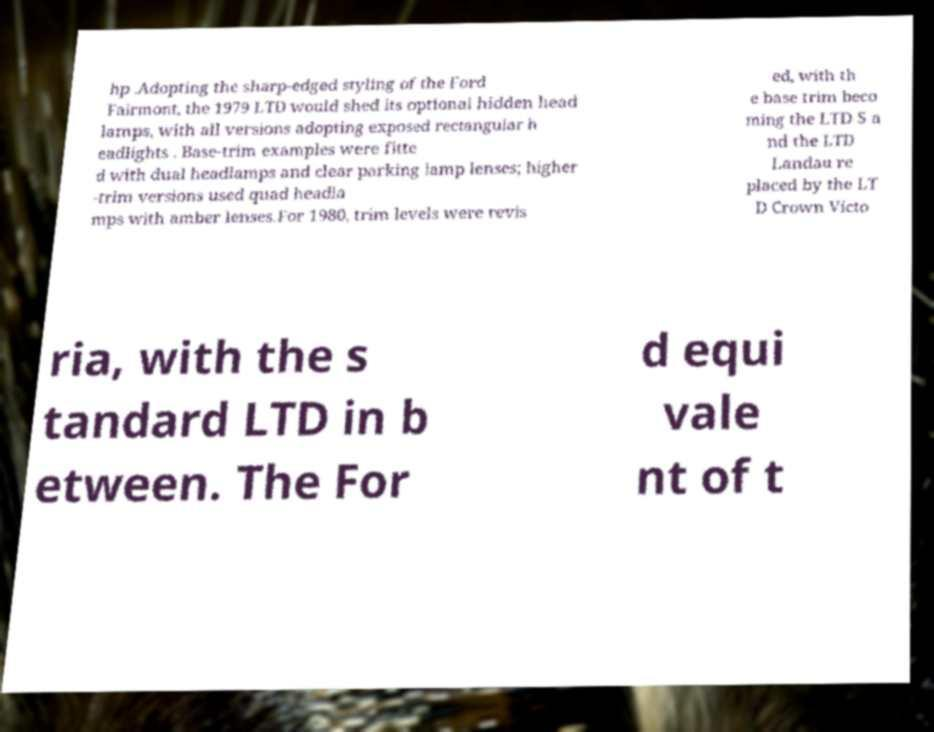Can you read and provide the text displayed in the image?This photo seems to have some interesting text. Can you extract and type it out for me? hp .Adopting the sharp-edged styling of the Ford Fairmont, the 1979 LTD would shed its optional hidden head lamps, with all versions adopting exposed rectangular h eadlights . Base-trim examples were fitte d with dual headlamps and clear parking lamp lenses; higher -trim versions used quad headla mps with amber lenses.For 1980, trim levels were revis ed, with th e base trim beco ming the LTD S a nd the LTD Landau re placed by the LT D Crown Victo ria, with the s tandard LTD in b etween. The For d equi vale nt of t 